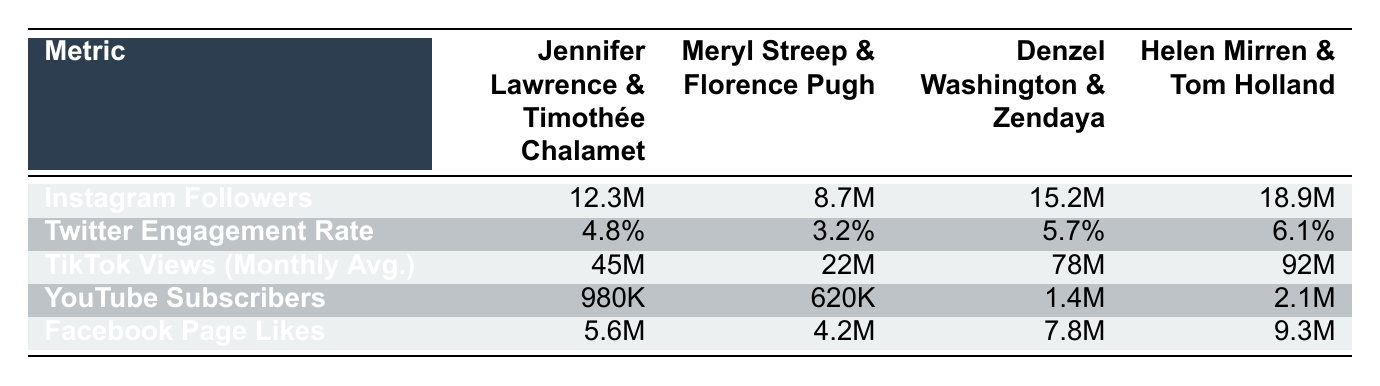What is the Instagram follower count for Helen Mirren & Tom Holland? The table shows the Instagram followers for each pair of actors. It lists Helen Mirren & Tom Holland with 18.9M followers.
Answer: 18.9M Which duo has the highest Twitter engagement rate? When comparing the Twitter engagement rates, Denzel Washington & Zendaya has the highest rate at 5.7%, followed closely by Helen Mirren & Tom Holland at 6.1%, making Helen Mirren & Tom Holland the highest.
Answer: Helen Mirren & Tom Holland Calculate the total monthly average TikTok views for all the pairs listed in the table. To find the total TikTok views, we add the monthly averages: 45M + 22M + 78M + 92M = 237M. Thus, the total is 237M.
Answer: 237M Who has more YouTube subscribers, Meryl Streep & Florence Pugh or Jennifer Lawrence & Timothée Chalamet? The table indicates that Meryl Streep & Florence Pugh has 620K YouTube subscribers, while Jennifer Lawrence & Timothée Chalamet has 980K. Therefore, Jennifer Lawrence & Timothée Chalamet has more subscribers.
Answer: Jennifer Lawrence & Timothée Chalamet Is it true that Denzel Washington & Zendaya have more Facebook Page Likes than Jennifer Lawrence & Timothée Chalamet? By examining the Facebook Page Likes, we see Denzel Washington & Zendaya have 7.8M, and Jennifer Lawrence & Timothée Chalamet has 5.6M. Since 7.8M is greater than 5.6M, the statement is true.
Answer: Yes 